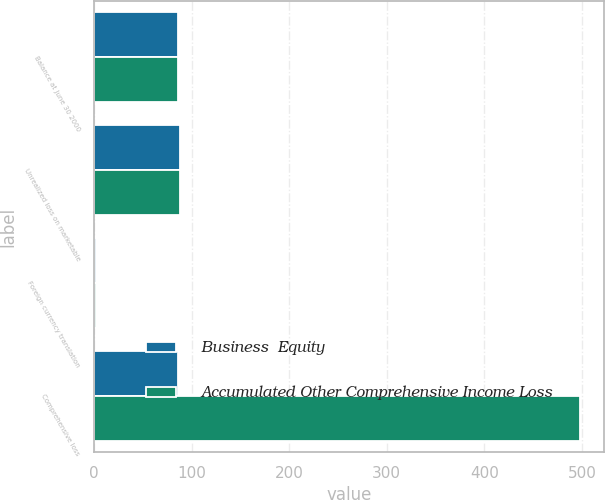Convert chart. <chart><loc_0><loc_0><loc_500><loc_500><stacked_bar_chart><ecel><fcel>Balance at June 30 2000<fcel>Unrealized loss on marketable<fcel>Foreign currency translation<fcel>Comprehensive loss<nl><fcel>Business  Equity<fcel>86<fcel>88<fcel>2<fcel>86<nl><fcel>Accumulated Other Comprehensive Income Loss<fcel>86<fcel>88<fcel>2<fcel>498<nl></chart> 